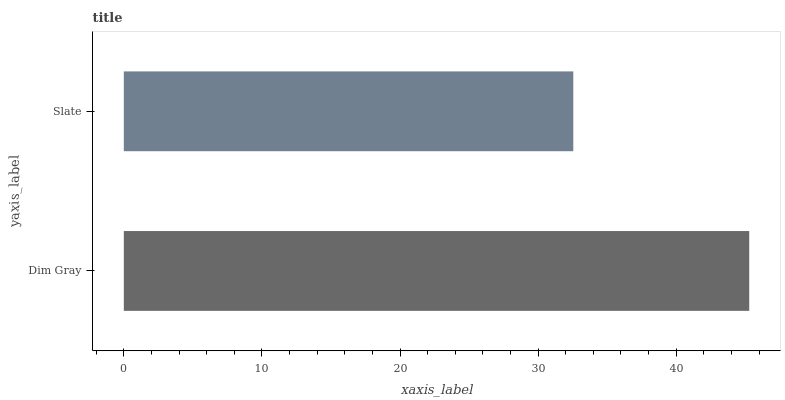Is Slate the minimum?
Answer yes or no. Yes. Is Dim Gray the maximum?
Answer yes or no. Yes. Is Slate the maximum?
Answer yes or no. No. Is Dim Gray greater than Slate?
Answer yes or no. Yes. Is Slate less than Dim Gray?
Answer yes or no. Yes. Is Slate greater than Dim Gray?
Answer yes or no. No. Is Dim Gray less than Slate?
Answer yes or no. No. Is Dim Gray the high median?
Answer yes or no. Yes. Is Slate the low median?
Answer yes or no. Yes. Is Slate the high median?
Answer yes or no. No. Is Dim Gray the low median?
Answer yes or no. No. 